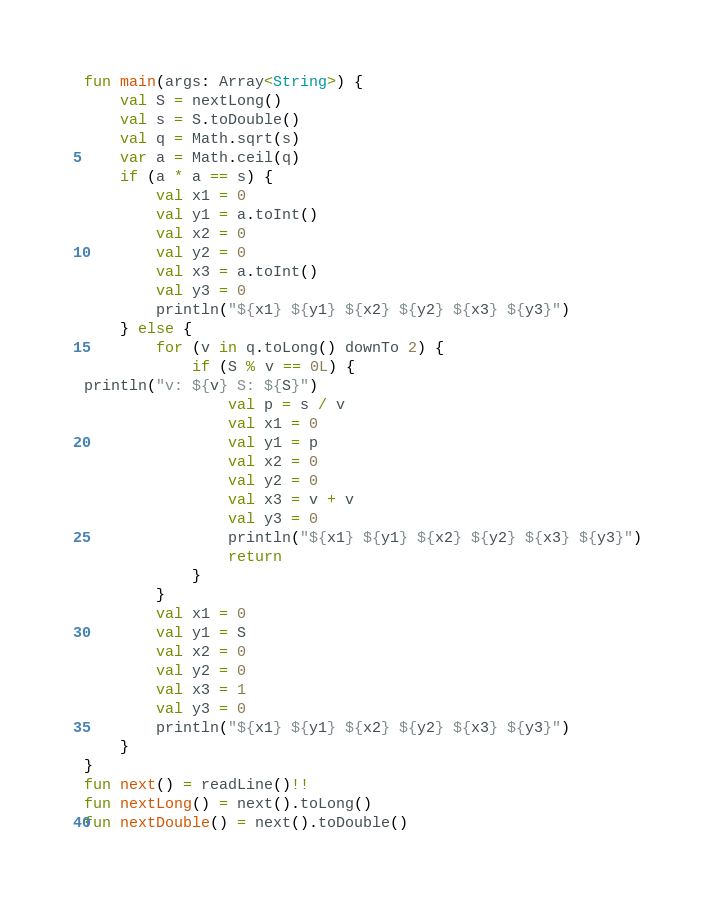Convert code to text. <code><loc_0><loc_0><loc_500><loc_500><_Kotlin_>fun main(args: Array<String>) {
    val S = nextLong()
    val s = S.toDouble()
    val q = Math.sqrt(s)
    var a = Math.ceil(q)
    if (a * a == s) {
        val x1 = 0
        val y1 = a.toInt()
        val x2 = 0
        val y2 = 0
        val x3 = a.toInt()
        val y3 = 0
        println("${x1} ${y1} ${x2} ${y2} ${x3} ${y3}")
    } else {
        for (v in q.toLong() downTo 2) {
            if (S % v == 0L) {
println("v: ${v} S: ${S}")
                val p = s / v
                val x1 = 0
                val y1 = p
                val x2 = 0
                val y2 = 0
                val x3 = v + v
                val y3 = 0
                println("${x1} ${y1} ${x2} ${y2} ${x3} ${y3}")
                return
            }
        }
        val x1 = 0
        val y1 = S
        val x2 = 0
        val y2 = 0
        val x3 = 1
        val y3 = 0
        println("${x1} ${y1} ${x2} ${y2} ${x3} ${y3}")
    }
}
fun next() = readLine()!!
fun nextLong() = next().toLong()
fun nextDouble() = next().toDouble()
</code> 